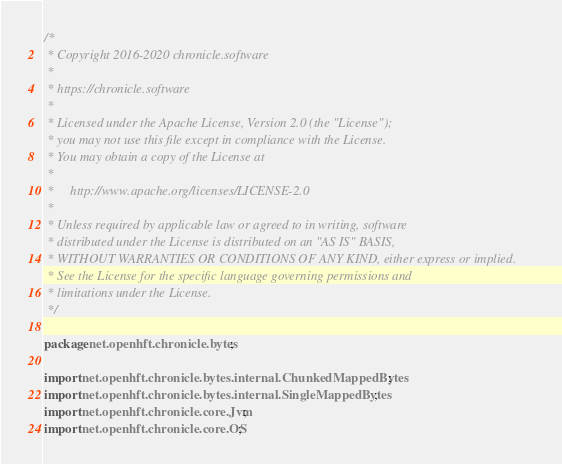<code> <loc_0><loc_0><loc_500><loc_500><_Java_>/*
 * Copyright 2016-2020 chronicle.software
 *
 * https://chronicle.software
 *
 * Licensed under the Apache License, Version 2.0 (the "License");
 * you may not use this file except in compliance with the License.
 * You may obtain a copy of the License at
 *
 *     http://www.apache.org/licenses/LICENSE-2.0
 *
 * Unless required by applicable law or agreed to in writing, software
 * distributed under the License is distributed on an "AS IS" BASIS,
 * WITHOUT WARRANTIES OR CONDITIONS OF ANY KIND, either express or implied.
 * See the License for the specific language governing permissions and
 * limitations under the License.
 */

package net.openhft.chronicle.bytes;

import net.openhft.chronicle.bytes.internal.ChunkedMappedBytes;
import net.openhft.chronicle.bytes.internal.SingleMappedBytes;
import net.openhft.chronicle.core.Jvm;
import net.openhft.chronicle.core.OS;</code> 